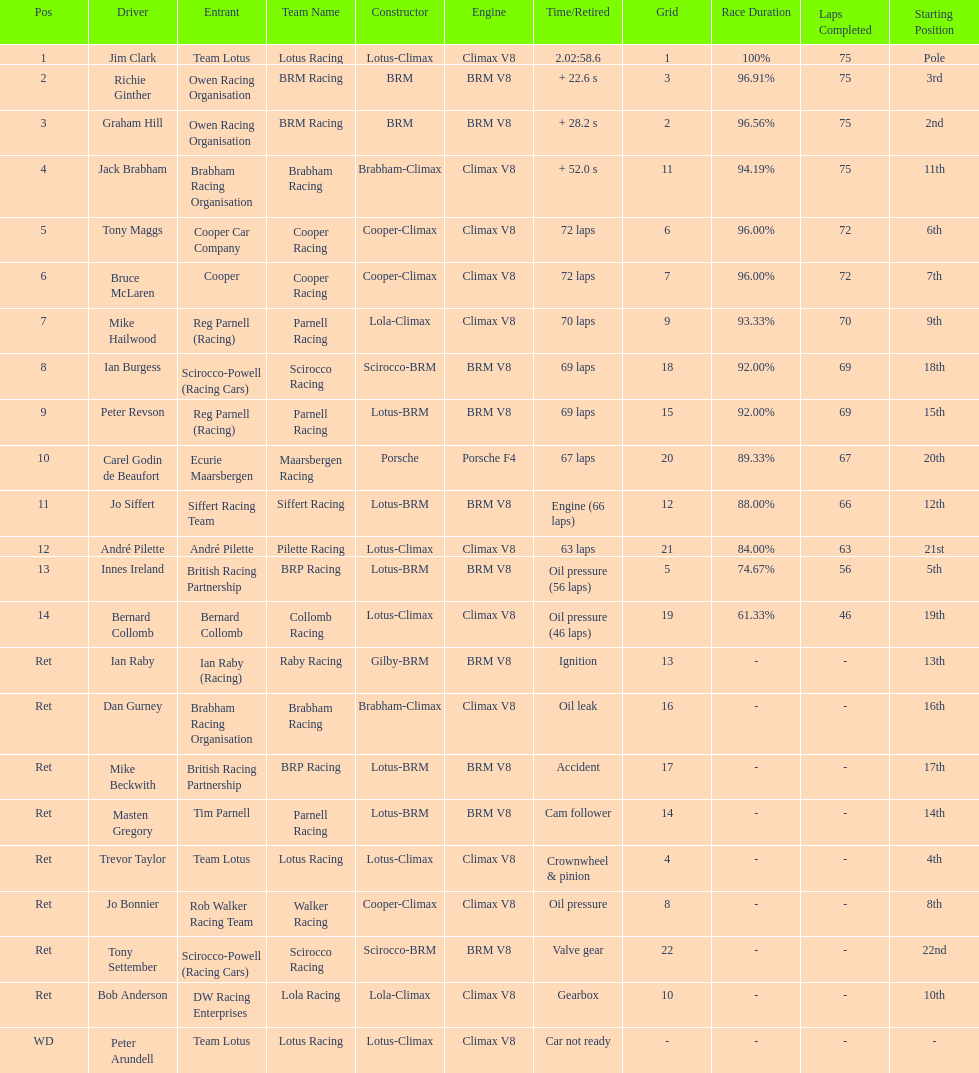How many different drivers are listed? 23. 